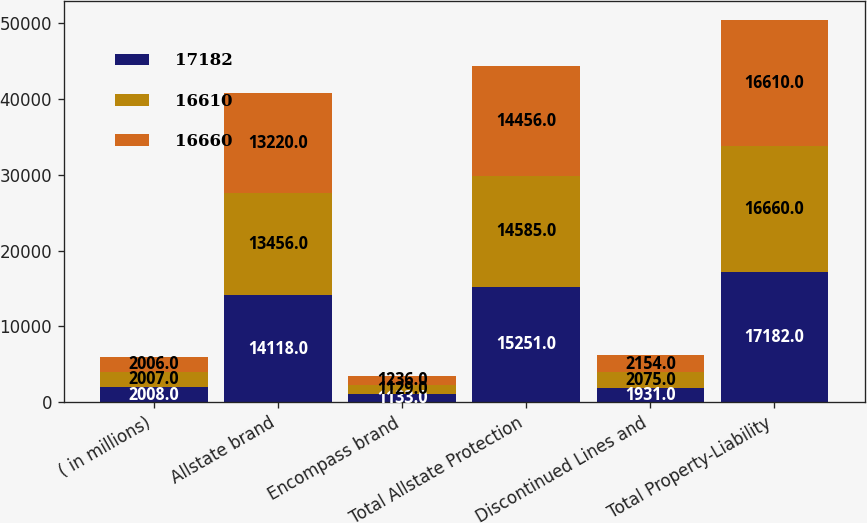<chart> <loc_0><loc_0><loc_500><loc_500><stacked_bar_chart><ecel><fcel>( in millions)<fcel>Allstate brand<fcel>Encompass brand<fcel>Total Allstate Protection<fcel>Discontinued Lines and<fcel>Total Property-Liability<nl><fcel>17182<fcel>2008<fcel>14118<fcel>1133<fcel>15251<fcel>1931<fcel>17182<nl><fcel>16610<fcel>2007<fcel>13456<fcel>1129<fcel>14585<fcel>2075<fcel>16660<nl><fcel>16660<fcel>2006<fcel>13220<fcel>1236<fcel>14456<fcel>2154<fcel>16610<nl></chart> 